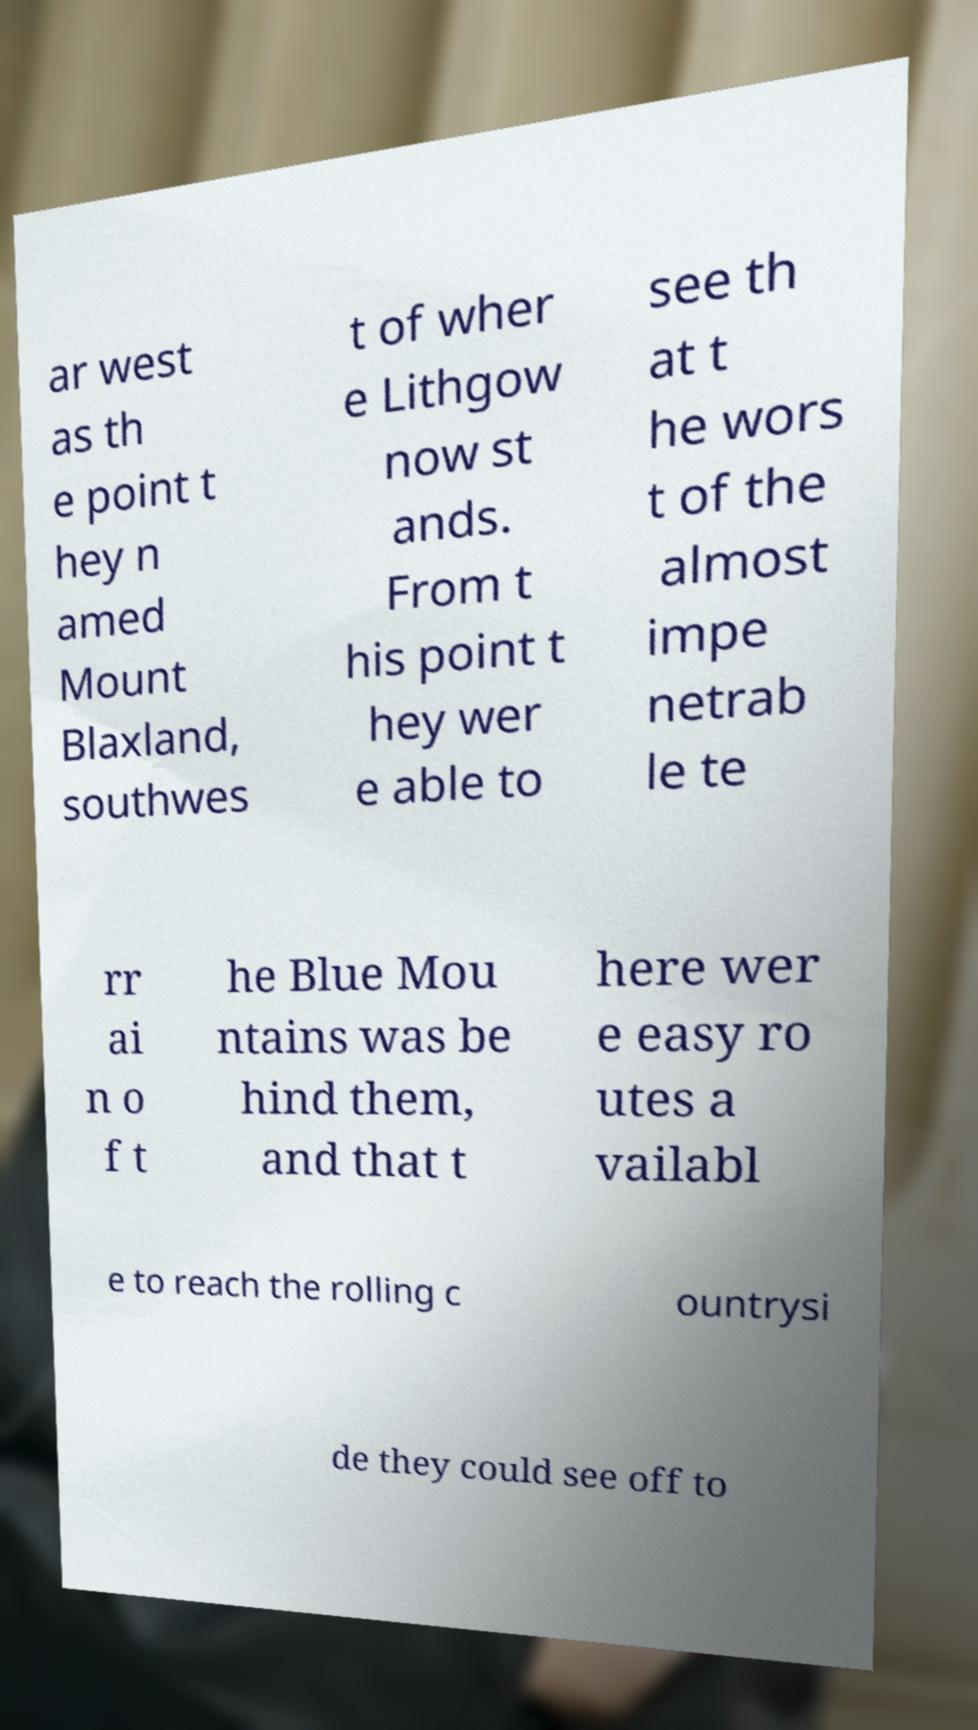Please read and relay the text visible in this image. What does it say? ar west as th e point t hey n amed Mount Blaxland, southwes t of wher e Lithgow now st ands. From t his point t hey wer e able to see th at t he wors t of the almost impe netrab le te rr ai n o f t he Blue Mou ntains was be hind them, and that t here wer e easy ro utes a vailabl e to reach the rolling c ountrysi de they could see off to 